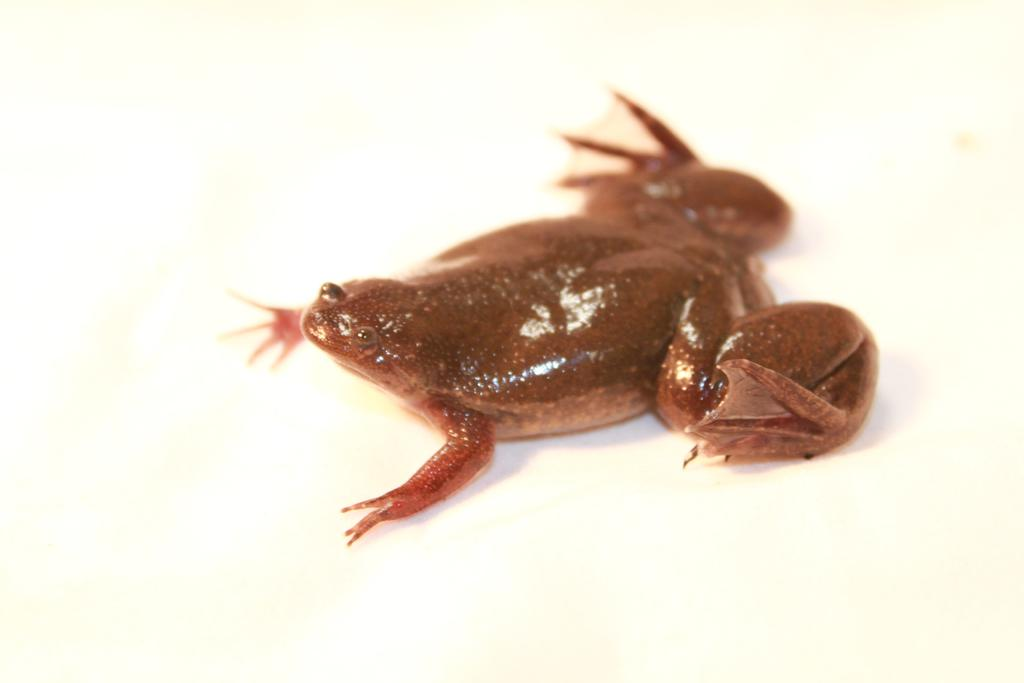What type of animal is in the image? There is a brown frog in the image. Where is the frog located in the image? The frog is on the floor. What type of tools does the frog use as a carpenter in the image? There is no indication in the image that the frog is a carpenter or using any tools. 